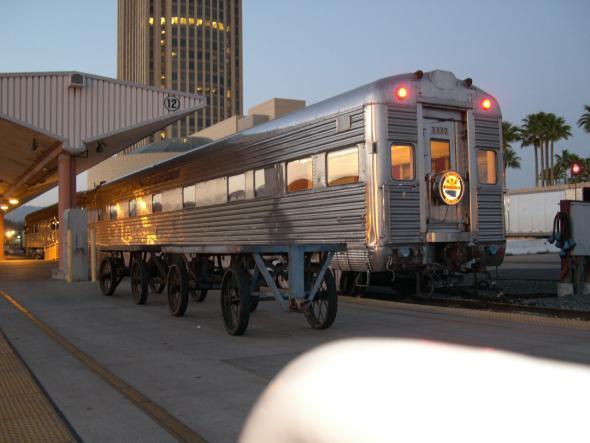Is this a European train station?
Short answer required. Yes. What color is the train?
Be succinct. Silver. What is the number of this platform?
Write a very short answer. 12. 